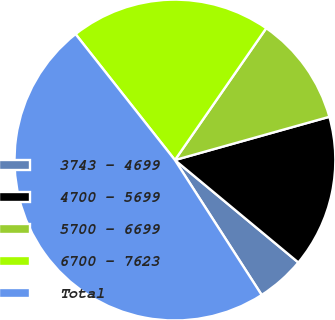Convert chart. <chart><loc_0><loc_0><loc_500><loc_500><pie_chart><fcel>3743 - 4699<fcel>4700 - 5699<fcel>5700 - 6699<fcel>6700 - 7623<fcel>Total<nl><fcel>4.88%<fcel>15.37%<fcel>11.01%<fcel>20.27%<fcel>48.46%<nl></chart> 